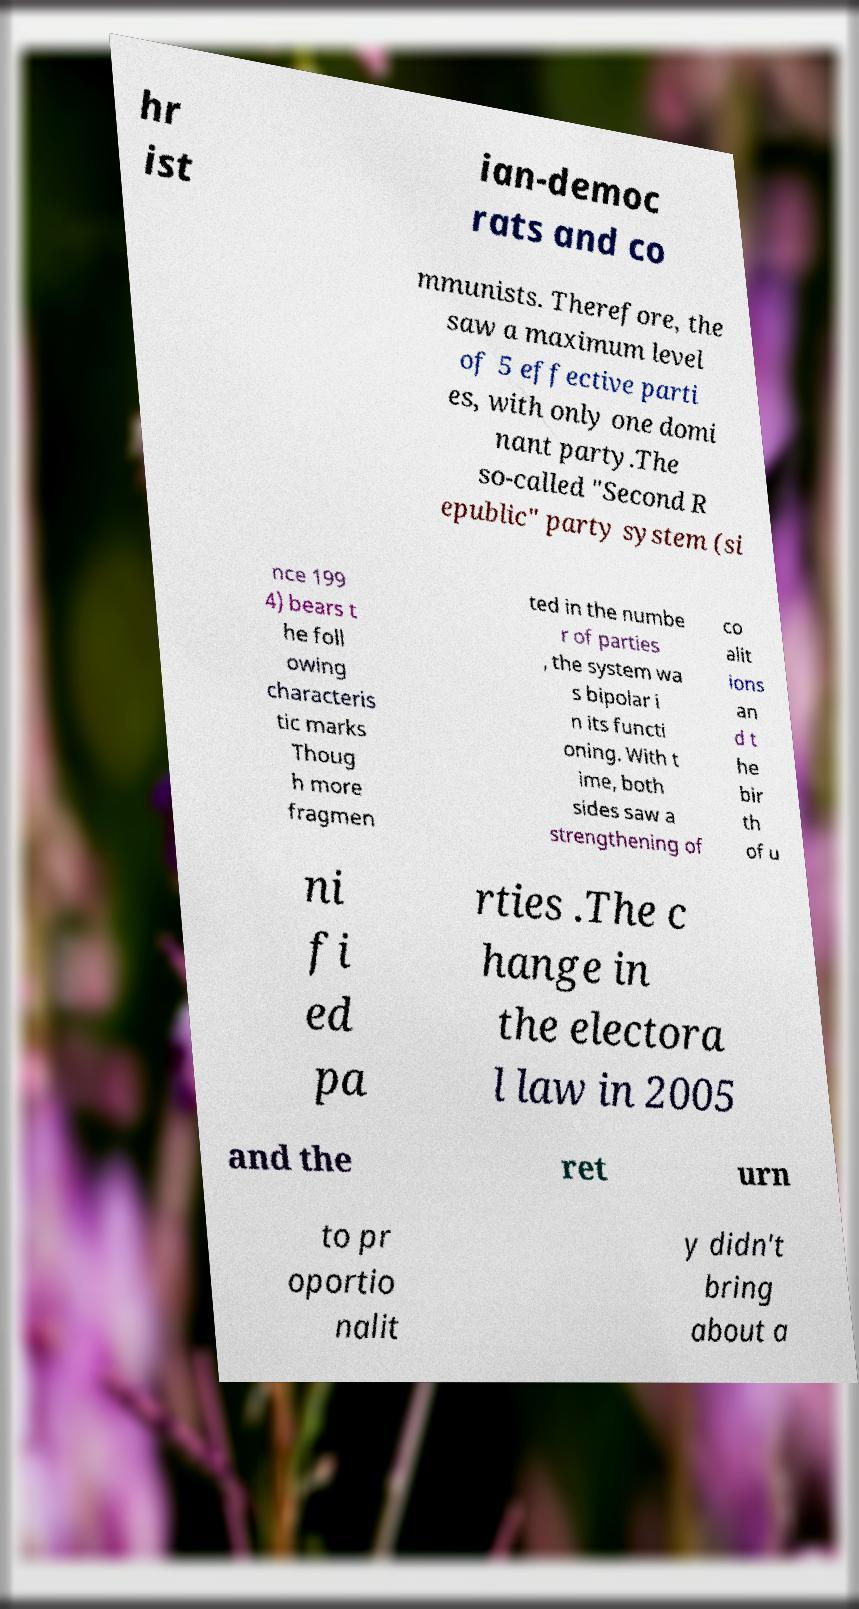Could you assist in decoding the text presented in this image and type it out clearly? hr ist ian-democ rats and co mmunists. Therefore, the saw a maximum level of 5 effective parti es, with only one domi nant party.The so-called "Second R epublic" party system (si nce 199 4) bears t he foll owing characteris tic marks Thoug h more fragmen ted in the numbe r of parties , the system wa s bipolar i n its functi oning. With t ime, both sides saw a strengthening of co alit ions an d t he bir th of u ni fi ed pa rties .The c hange in the electora l law in 2005 and the ret urn to pr oportio nalit y didn't bring about a 